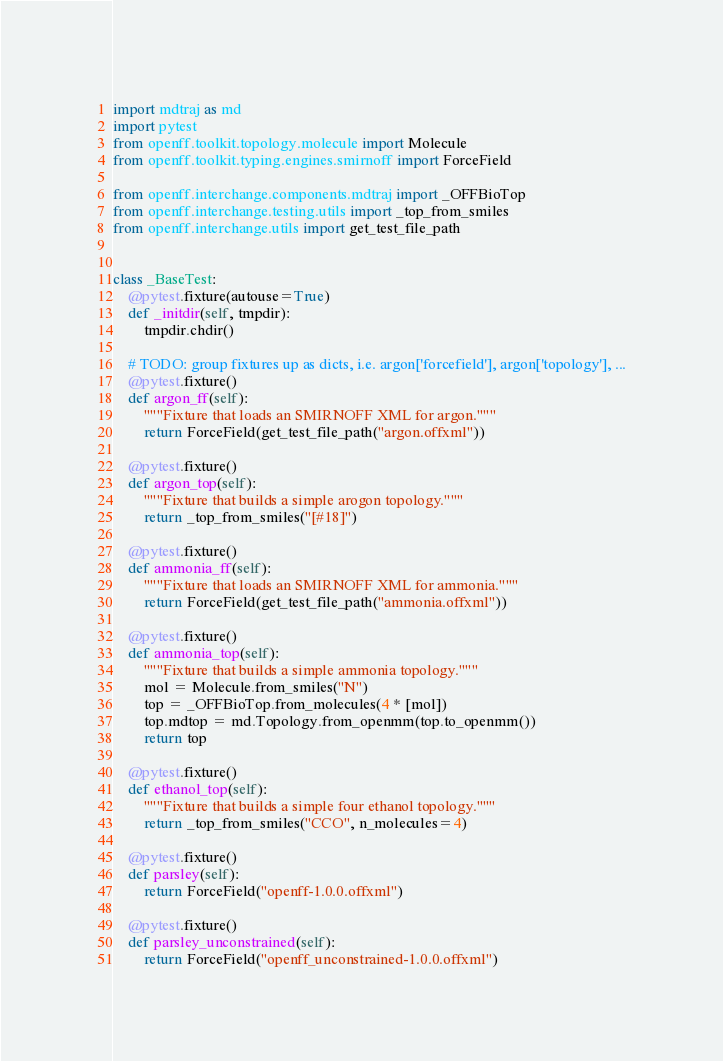<code> <loc_0><loc_0><loc_500><loc_500><_Python_>import mdtraj as md
import pytest
from openff.toolkit.topology.molecule import Molecule
from openff.toolkit.typing.engines.smirnoff import ForceField

from openff.interchange.components.mdtraj import _OFFBioTop
from openff.interchange.testing.utils import _top_from_smiles
from openff.interchange.utils import get_test_file_path


class _BaseTest:
    @pytest.fixture(autouse=True)
    def _initdir(self, tmpdir):
        tmpdir.chdir()

    # TODO: group fixtures up as dicts, i.e. argon['forcefield'], argon['topology'], ...
    @pytest.fixture()
    def argon_ff(self):
        """Fixture that loads an SMIRNOFF XML for argon."""
        return ForceField(get_test_file_path("argon.offxml"))

    @pytest.fixture()
    def argon_top(self):
        """Fixture that builds a simple arogon topology."""
        return _top_from_smiles("[#18]")

    @pytest.fixture()
    def ammonia_ff(self):
        """Fixture that loads an SMIRNOFF XML for ammonia."""
        return ForceField(get_test_file_path("ammonia.offxml"))

    @pytest.fixture()
    def ammonia_top(self):
        """Fixture that builds a simple ammonia topology."""
        mol = Molecule.from_smiles("N")
        top = _OFFBioTop.from_molecules(4 * [mol])
        top.mdtop = md.Topology.from_openmm(top.to_openmm())
        return top

    @pytest.fixture()
    def ethanol_top(self):
        """Fixture that builds a simple four ethanol topology."""
        return _top_from_smiles("CCO", n_molecules=4)

    @pytest.fixture()
    def parsley(self):
        return ForceField("openff-1.0.0.offxml")

    @pytest.fixture()
    def parsley_unconstrained(self):
        return ForceField("openff_unconstrained-1.0.0.offxml")
</code> 